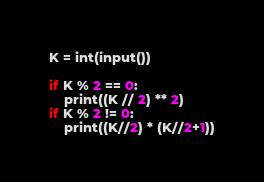<code> <loc_0><loc_0><loc_500><loc_500><_Python_>K = int(input())

if K % 2 == 0:
    print((K // 2) ** 2)
if K % 2 != 0:
    print((K//2) * (K//2+1))</code> 